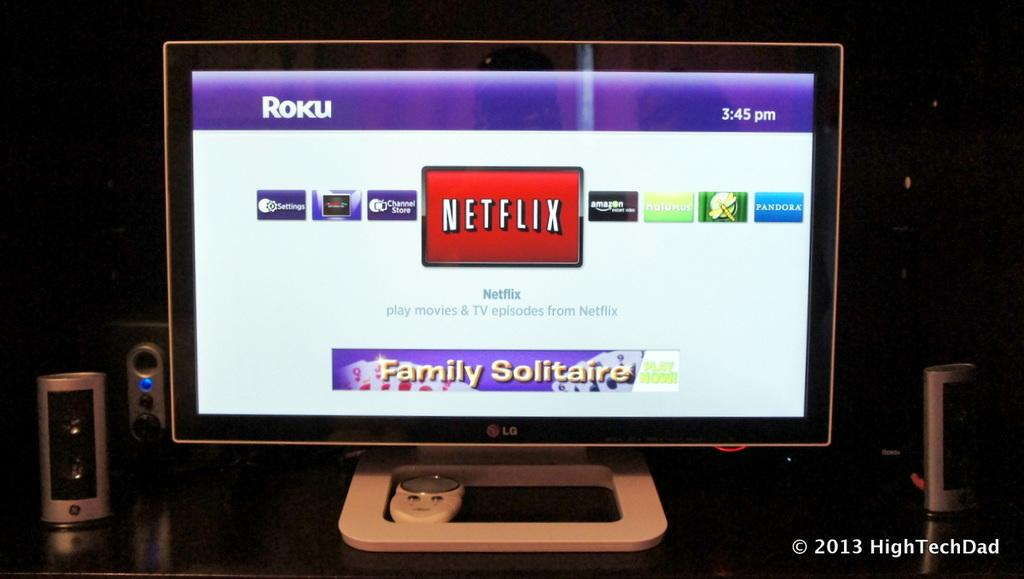<image>
Offer a succinct explanation of the picture presented. An LG Roku Tv is open to a screen with the Netflix app highlighted. 